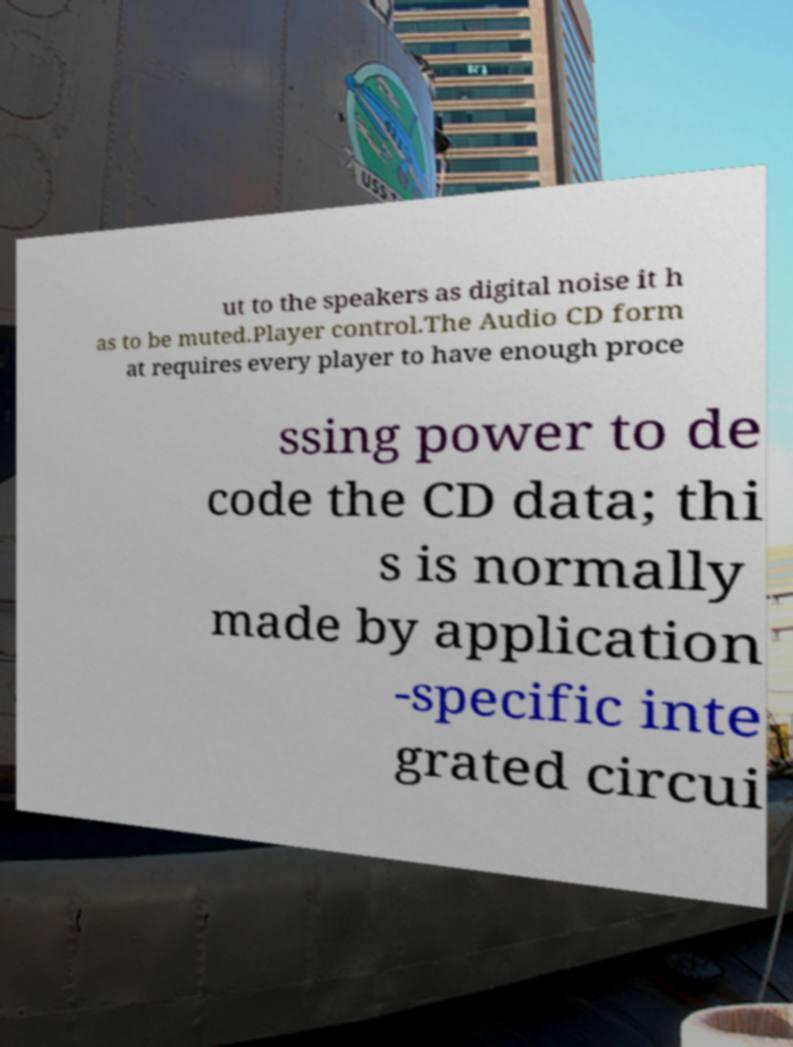Could you assist in decoding the text presented in this image and type it out clearly? ut to the speakers as digital noise it h as to be muted.Player control.The Audio CD form at requires every player to have enough proce ssing power to de code the CD data; thi s is normally made by application -specific inte grated circui 